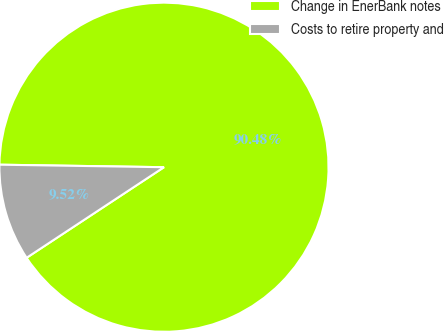Convert chart. <chart><loc_0><loc_0><loc_500><loc_500><pie_chart><fcel>Change in EnerBank notes<fcel>Costs to retire property and<nl><fcel>90.48%<fcel>9.52%<nl></chart> 